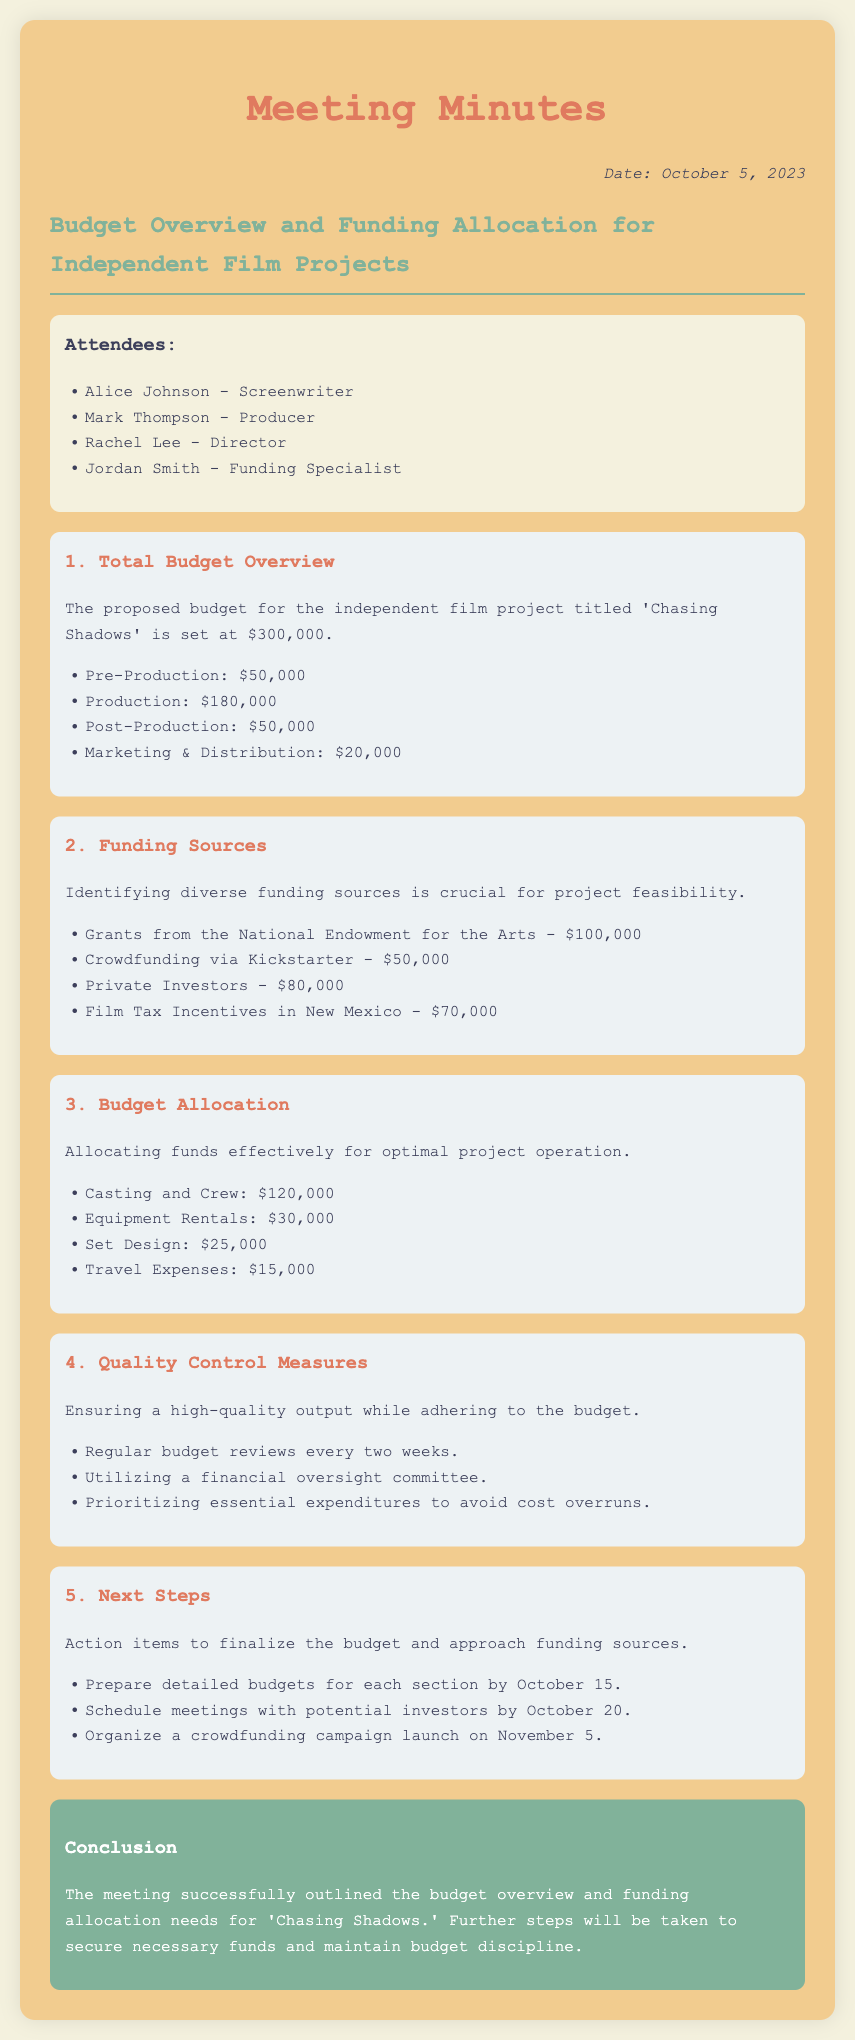What is the proposed budget for 'Chasing Shadows'? The proposed budget is stated clearly in the document as $300,000.
Answer: $300,000 Who is the funding specialist present at the meeting? The document lists Jordan Smith as the funding specialist in the attendees section.
Answer: Jordan Smith What is the budget allocation for Casting and Crew? This information can be retrieved from the budget allocation section of the document, which states $120,000.
Answer: $120,000 What are the three main categories of the budget? The document outlines four categories of the budget, including Pre-Production, Production, Post-Production, and Marketing & Distribution.
Answer: Pre-Production, Production, Post-Production, Marketing & Distribution Which funding source provides the highest amount? The funding sources section of the document indicates that Grants from the National Endowment for the Arts contribute the highest amount, which is $100,000.
Answer: Grants from the National Endowment for the Arts What is the total amount allocated for Marketing & Distribution? This information can be found under the total budget overview, which specifies $20,000 for Marketing & Distribution.
Answer: $20,000 What is the date by which detailed budgets for each section need to be prepared? The document specifies a deadline of October 15 for preparing detailed budgets.
Answer: October 15 How often will budget reviews occur? The quality control measures in the document state that budget reviews will occur every two weeks.
Answer: Every two weeks What is a key measure mentioned for maintaining budget discipline? The document outlines utilizing a financial oversight committee as a key measure to maintain budget discipline.
Answer: Financial oversight committee 